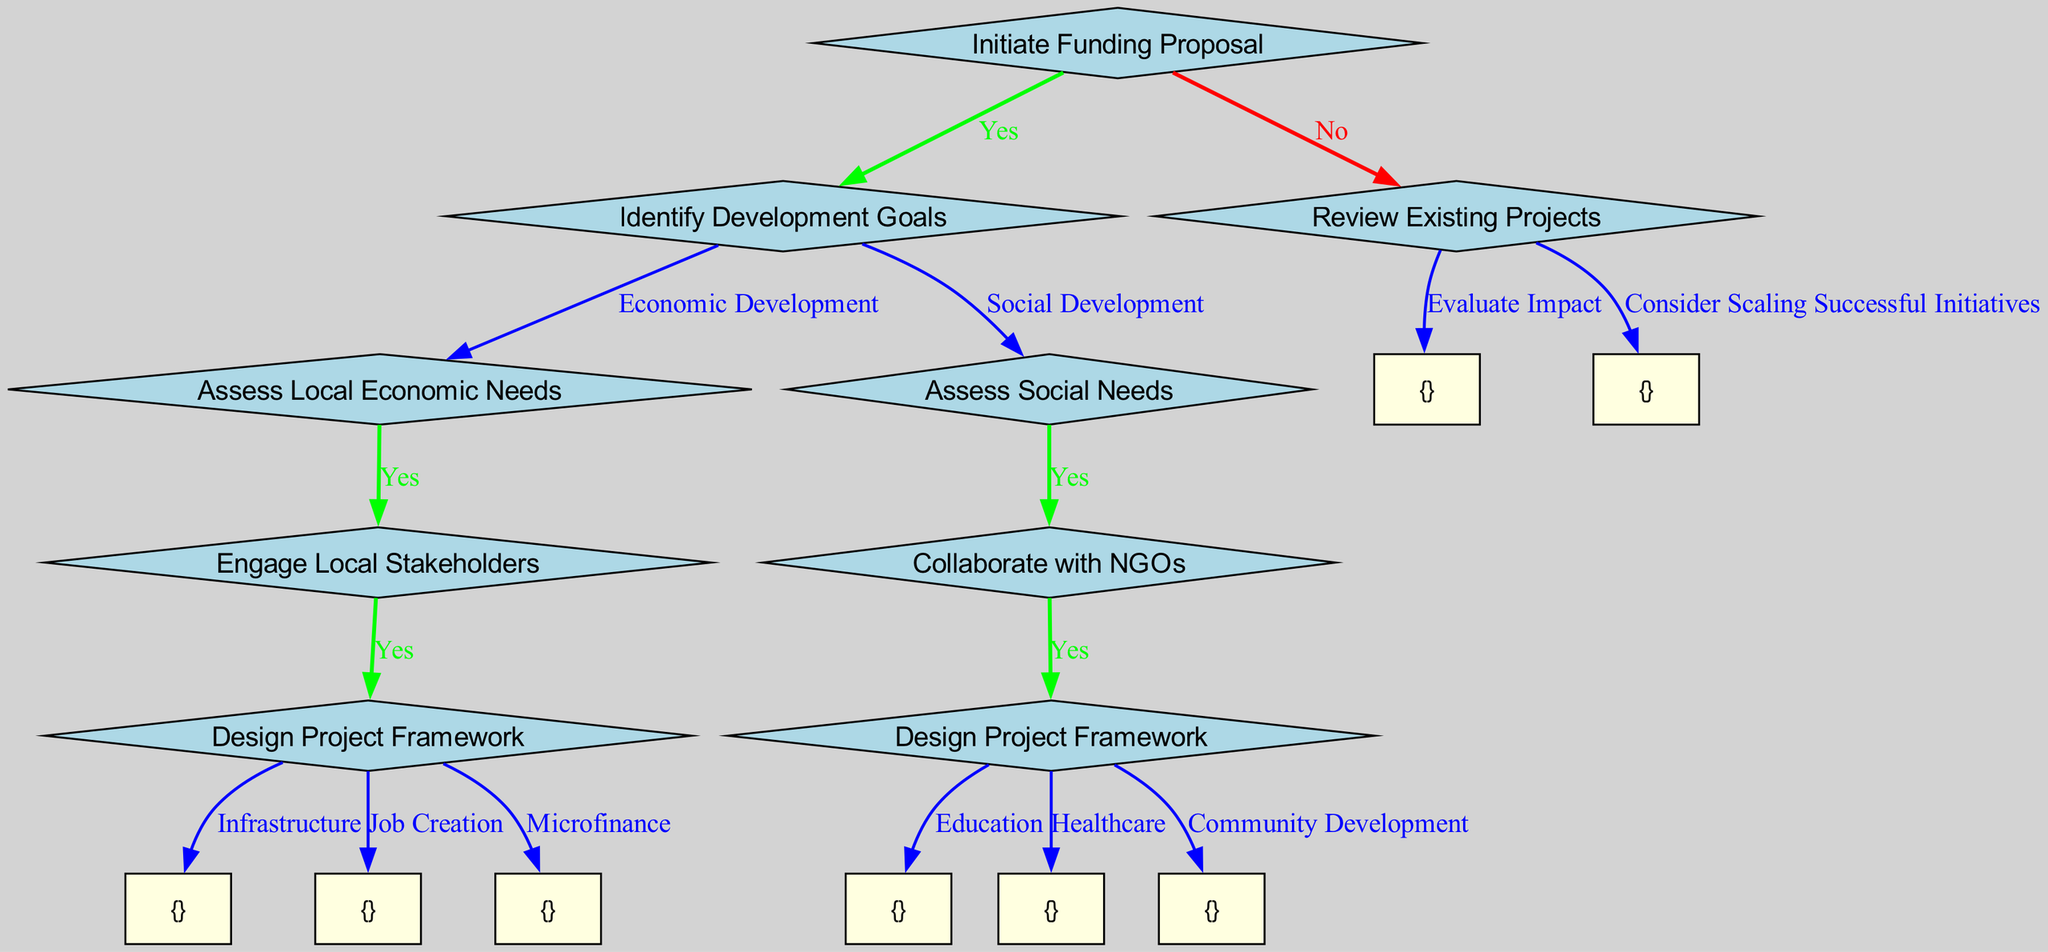What is the first question in the decision tree? The first question in the decision tree is located at the root node, which asks: "Initiate Funding Proposal". This is the initial query that guides the subsequent decisions in the process.
Answer: Initiate Funding Proposal How many options are provided under "Design Project Framework" for Economic Development? Under the Economic Development pathway, the "Design Project Framework" leads to three options: Infrastructure, Job Creation, and Microfinance. There are a total of three options presented in this part of the diagram.
Answer: 3 What is the consequence if the answer to "Engage Local Stakeholders" is No? If the answer to "Engage Local Stakeholders" is No, there are no further nodes or pathways to follow, indicating that this process would likely terminate without further development in that area. Therefore, the outcome is a dead-end in the flow.
Answer: No further action Which path leads to "Healthcare"? The path to "Healthcare" begins with saying Yes to "Initiate Funding Proposal", then Yes to "Identify Development Goals", followed by selecting "Social Development", saying Yes to "Assess Social Needs", then Yes to "Collaborate with NGOs", and finally leads to "Healthcare" as an option in "Design Project Framework".
Answer: Social Development > Assess Social Needs > Collaborate with NGOs > Healthcare What happens if the answer to "Review Existing Projects" is "Consider Scaling Successful Initiatives"? If the answer to "Review Existing Projects" is "Consider Scaling Successful Initiatives", the diagram indicates that this option does not lead to any further questions or actions, thus implying a consideration without a specific follow-up in this decision tree.
Answer: Consideration without follow-up 